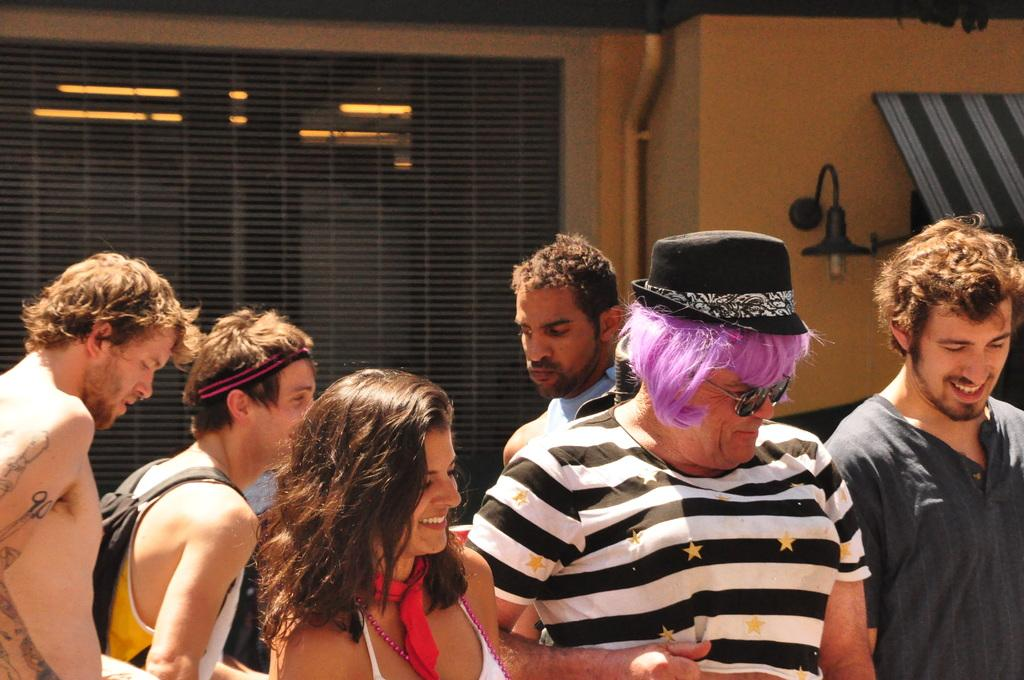Can you determine the setting of the image based on the available facts? The image was likely taken indoors. What is the main subject of the image? There is a group of persons in the foreground of the image. What can be seen in the background of the image? There is a wall, a wall lamp, and a window blind in the background of the image. Are there any other objects visible in the background? Yes, there are other unspecified items in the background of the image. What rule is being enforced by the root in the image? There is no root present in the image, and therefore no rule can be enforced. What is the purpose of the root in the image? There is no root present in the image, so it is impossible to determine its purpose. 